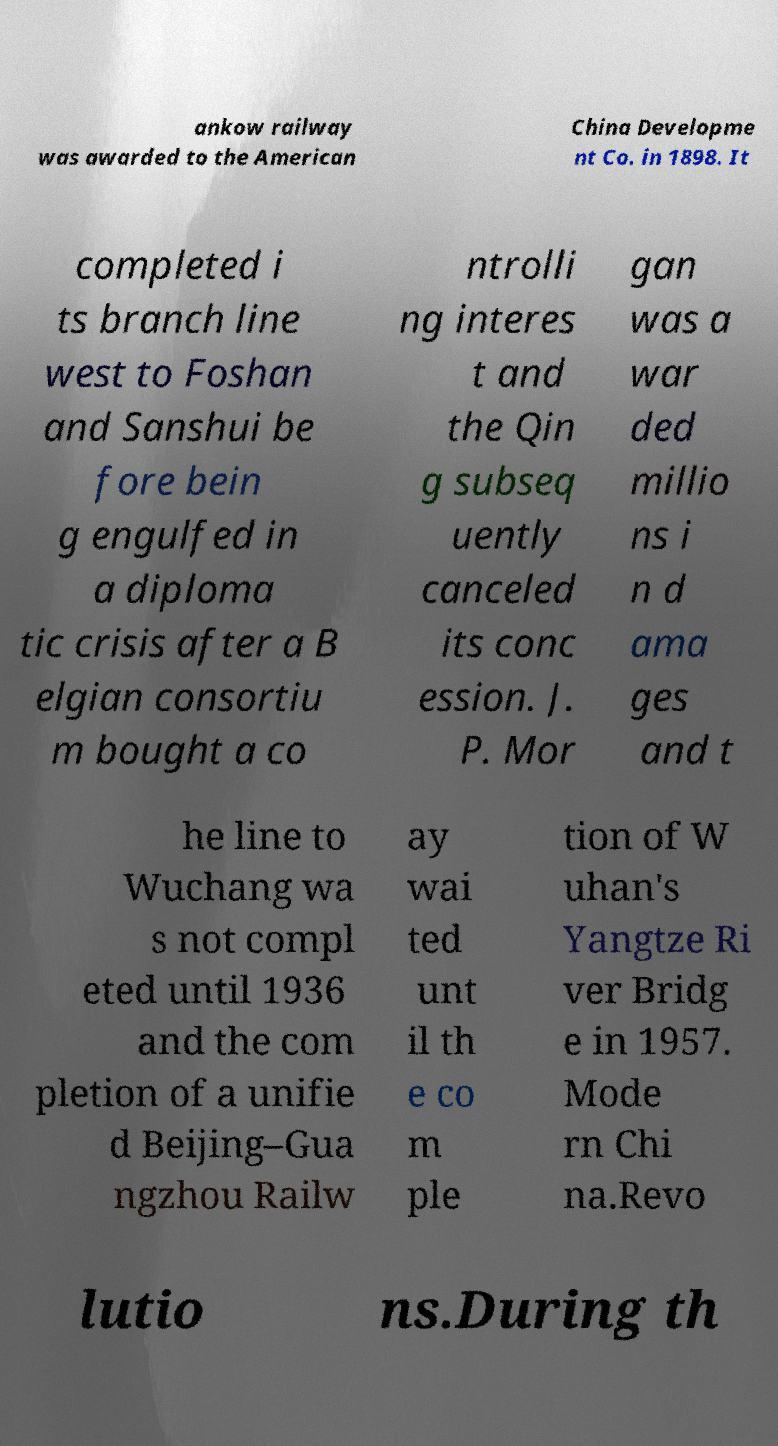Please read and relay the text visible in this image. What does it say? ankow railway was awarded to the American China Developme nt Co. in 1898. It completed i ts branch line west to Foshan and Sanshui be fore bein g engulfed in a diploma tic crisis after a B elgian consortiu m bought a co ntrolli ng interes t and the Qin g subseq uently canceled its conc ession. J. P. Mor gan was a war ded millio ns i n d ama ges and t he line to Wuchang wa s not compl eted until 1936 and the com pletion of a unifie d Beijing–Gua ngzhou Railw ay wai ted unt il th e co m ple tion of W uhan's Yangtze Ri ver Bridg e in 1957. Mode rn Chi na.Revo lutio ns.During th 